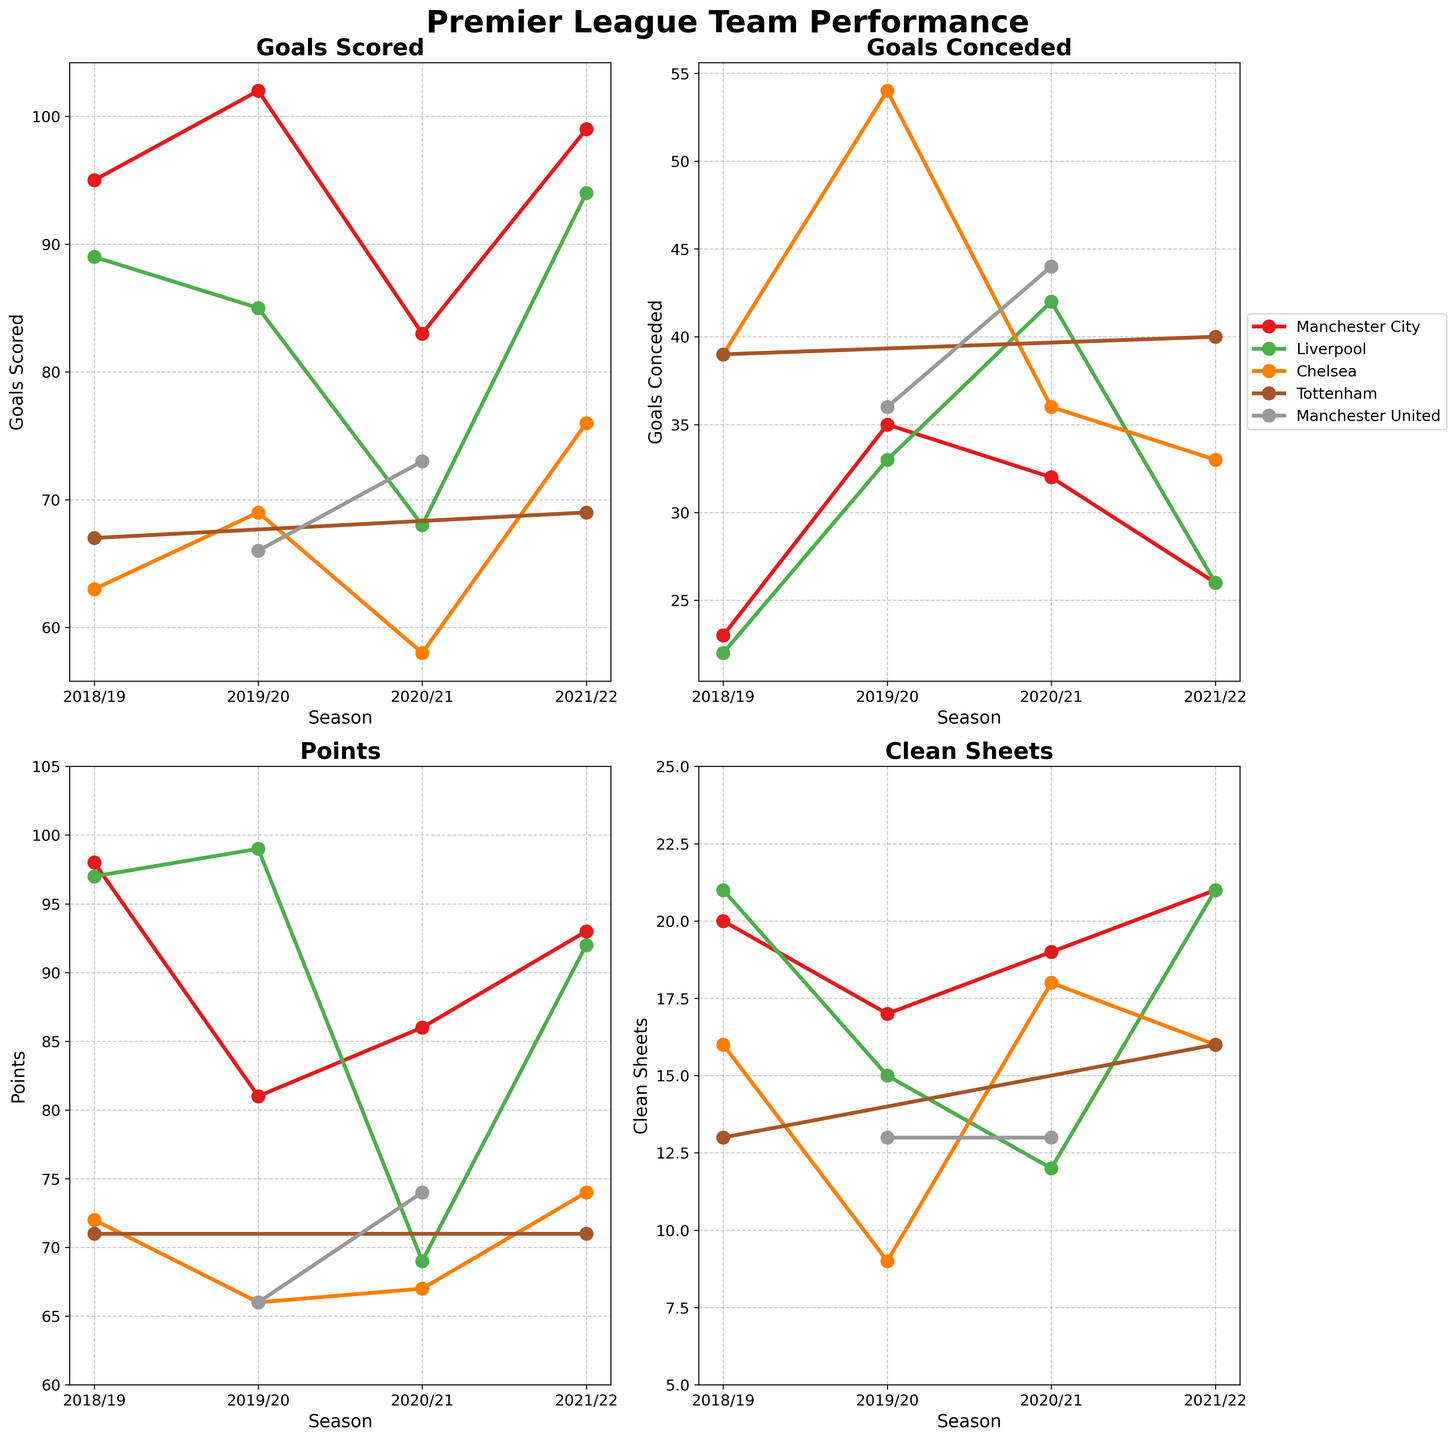What metric has the highest value in the plot? The available metrics in the plot are 'Goals Scored', 'Goals Conceded', 'Points', and 'Clean Sheets'. The highest values are: 'Goals Scored' - 102, 'Goals Conceded' - 54, 'Points' - 99, and 'Clean Sheets' - 21. Among these, 102 'Goals Scored' (Manchester City in 2019/20) is the highest value.
Answer: Goals Scored Which team had the most clean sheets in the 2021/22 season? To find this, look at the 'Clean Sheets' subplot for the 2021/22 season. Manchester City and Liverpool both had 21 clean sheets.
Answer: Manchester City and Liverpool What is the trend of goals scored by Liverpool across the seasons? To determine this, observe Liverpool's data points in the 'Goals Scored' subplot for each season. Liverpool scored 89 in 2018/19, 85 in 2019/20, 68 in 2020/21, and 94 in 2021/22. There's a trend of decrease from 2018/19 to 2020/21, then an increase in 2021/22.
Answer: Decrease, then increase Did any teams have seasons with exactly 69 points? In the 'Points' subplot, check for data points marking 69 points across seasons. Liverpool (2020/21) and Chelsea (2018/19) both had 69 points.
Answer: Liverpool and Chelsea How many clean sheets did Chelsea have in the 2019/20 season, and how did it compare to their 2020/21 season? First, find Chelsea's 'Clean Sheets' in 2019/20, which is 9. Then, see their clean sheets in 2020/21, which is 18. The difference is 18 - 9 = 9 more clean sheets in 2020/21.
Answer: 9 in 2019/20, 9 more in 2020/21 Which seasons did Manchester United have more than 70 points? In the 'Points' subplot, identify seasons where Manchester United's points exceed 70. These are the 2020/21 season with 74 points.
Answer: 2020/21 Compare the goals conceded by Tottenham Hotspur in 2018/19 and 2021/22. For 'Goals Conceded', find data for Tottenham in 2018/19 (which is 39) and 2021/22 (which is 40). The difference is 40 - 39 = 1 more goal conceded in 2021/22.
Answer: 39 in 2018/19, 40 in 2021/22 Which team showed the biggest improvement in points from the 2018/19 season to the 2021/22 season? Calculate the points improvement for each team from 2018/19 to 2021/22. Manchester City's points in 2018/19 were 98 and 93 in 2021/22 (-5 points); Liverpool's 97 to 92 (-5 points); Chelsea's 72 to 74 (+2 points). Chelsea had the biggest improvement.
Answer: Chelsea 